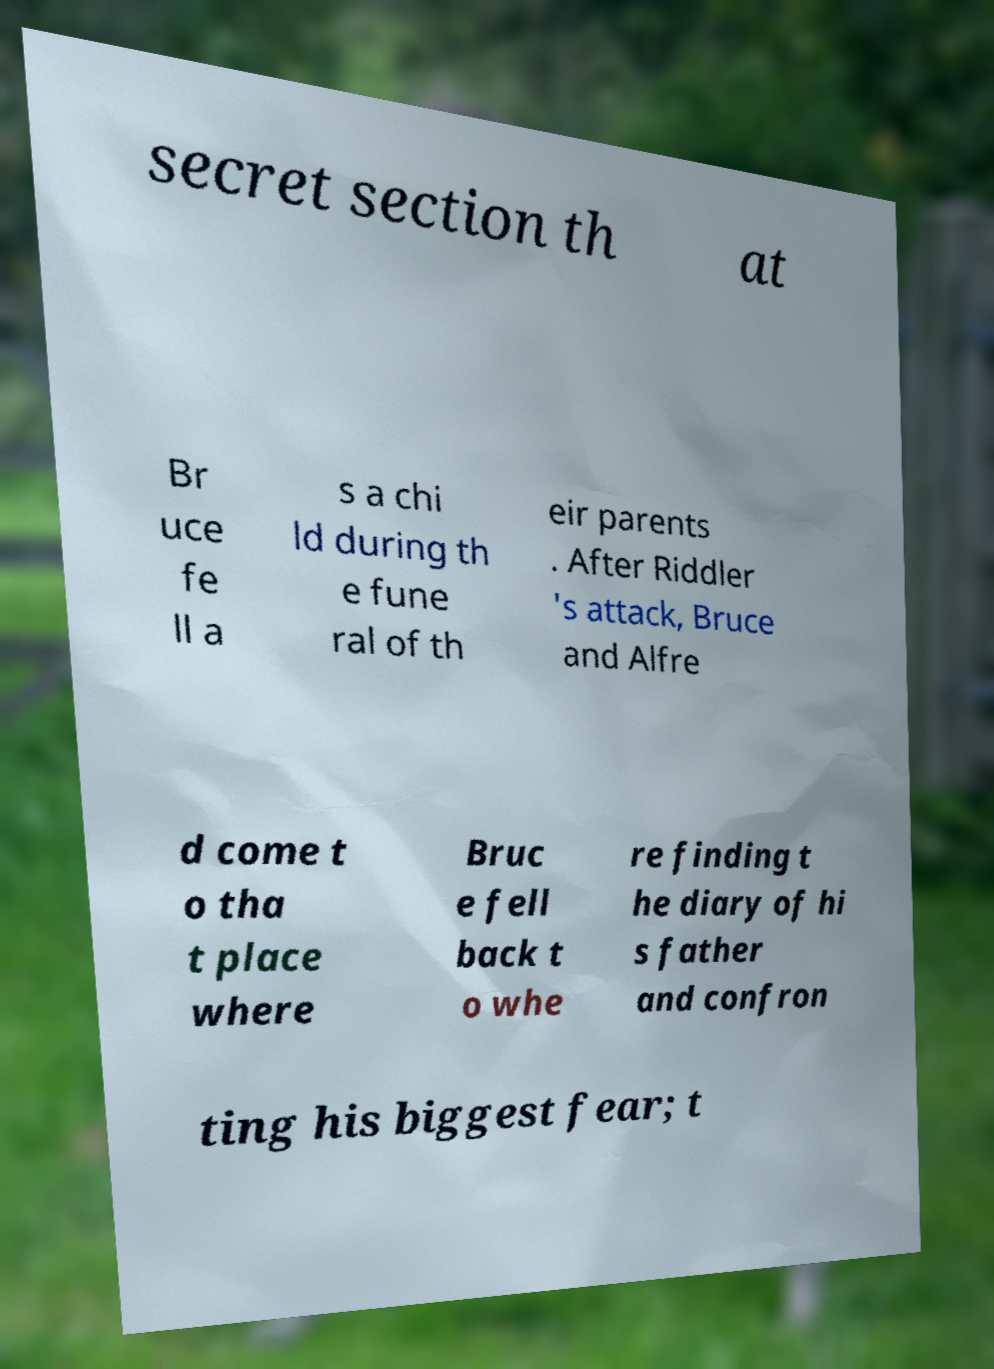There's text embedded in this image that I need extracted. Can you transcribe it verbatim? secret section th at Br uce fe ll a s a chi ld during th e fune ral of th eir parents . After Riddler 's attack, Bruce and Alfre d come t o tha t place where Bruc e fell back t o whe re finding t he diary of hi s father and confron ting his biggest fear; t 